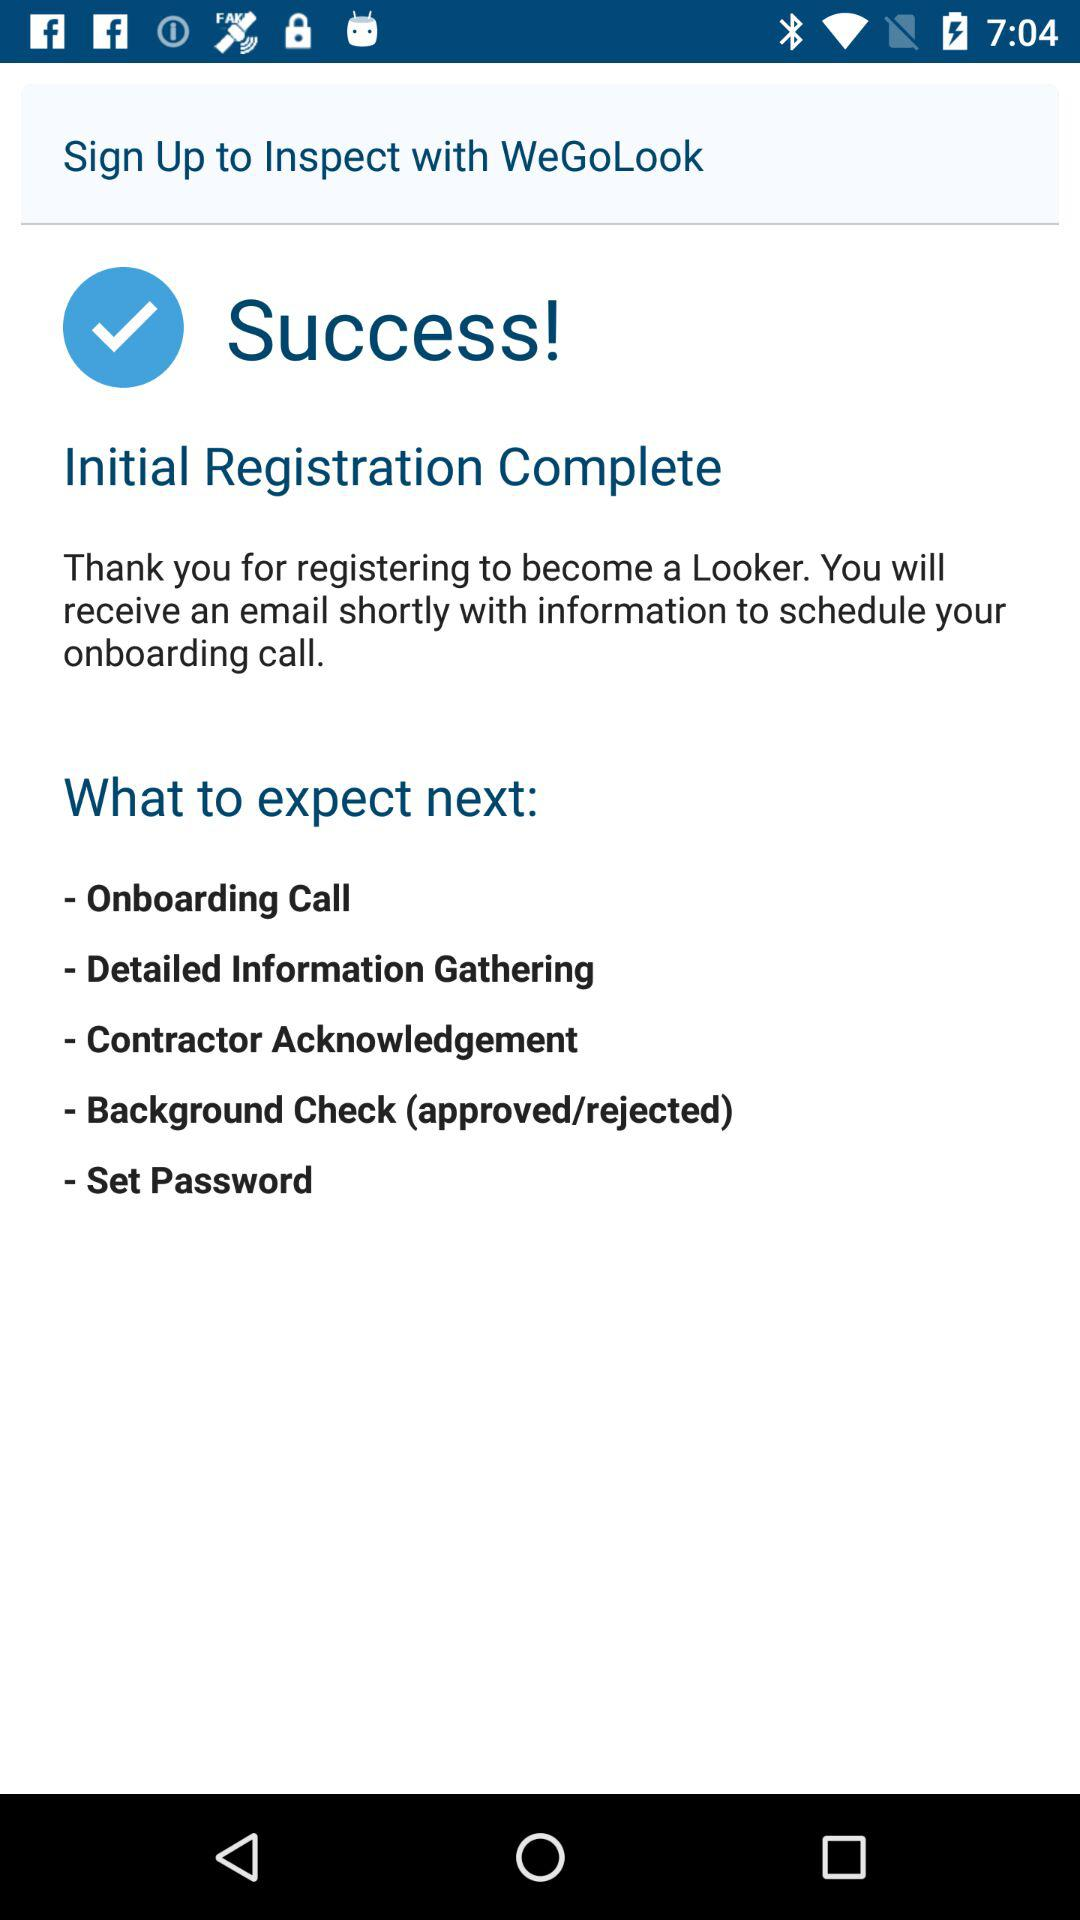How many steps are there in the onboarding process?
Answer the question using a single word or phrase. 5 